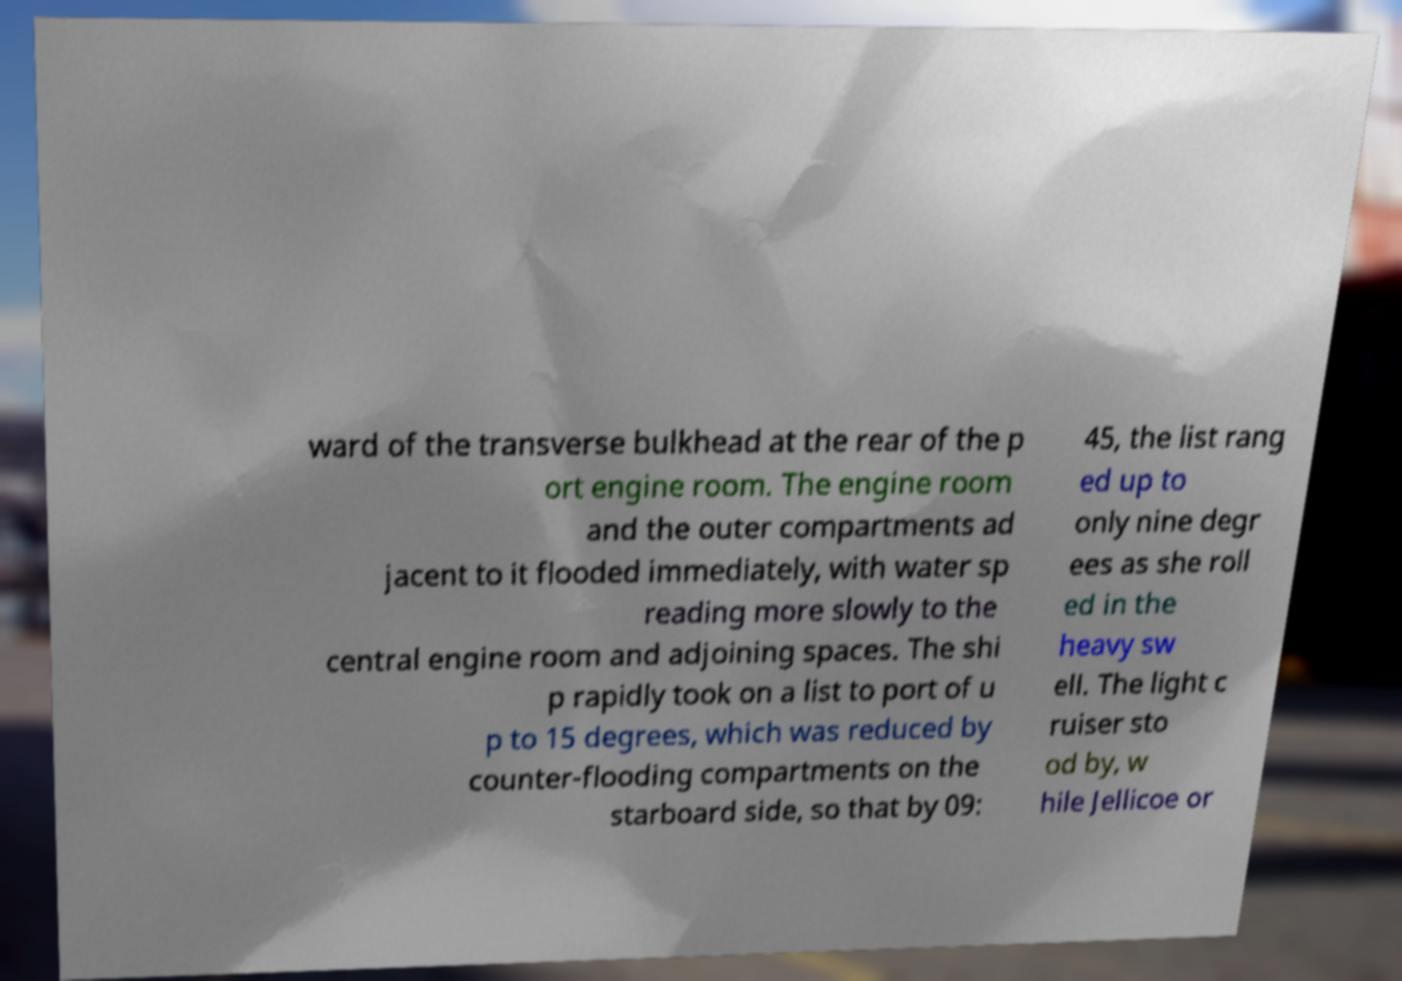Could you assist in decoding the text presented in this image and type it out clearly? ward of the transverse bulkhead at the rear of the p ort engine room. The engine room and the outer compartments ad jacent to it flooded immediately, with water sp reading more slowly to the central engine room and adjoining spaces. The shi p rapidly took on a list to port of u p to 15 degrees, which was reduced by counter-flooding compartments on the starboard side, so that by 09: 45, the list rang ed up to only nine degr ees as she roll ed in the heavy sw ell. The light c ruiser sto od by, w hile Jellicoe or 